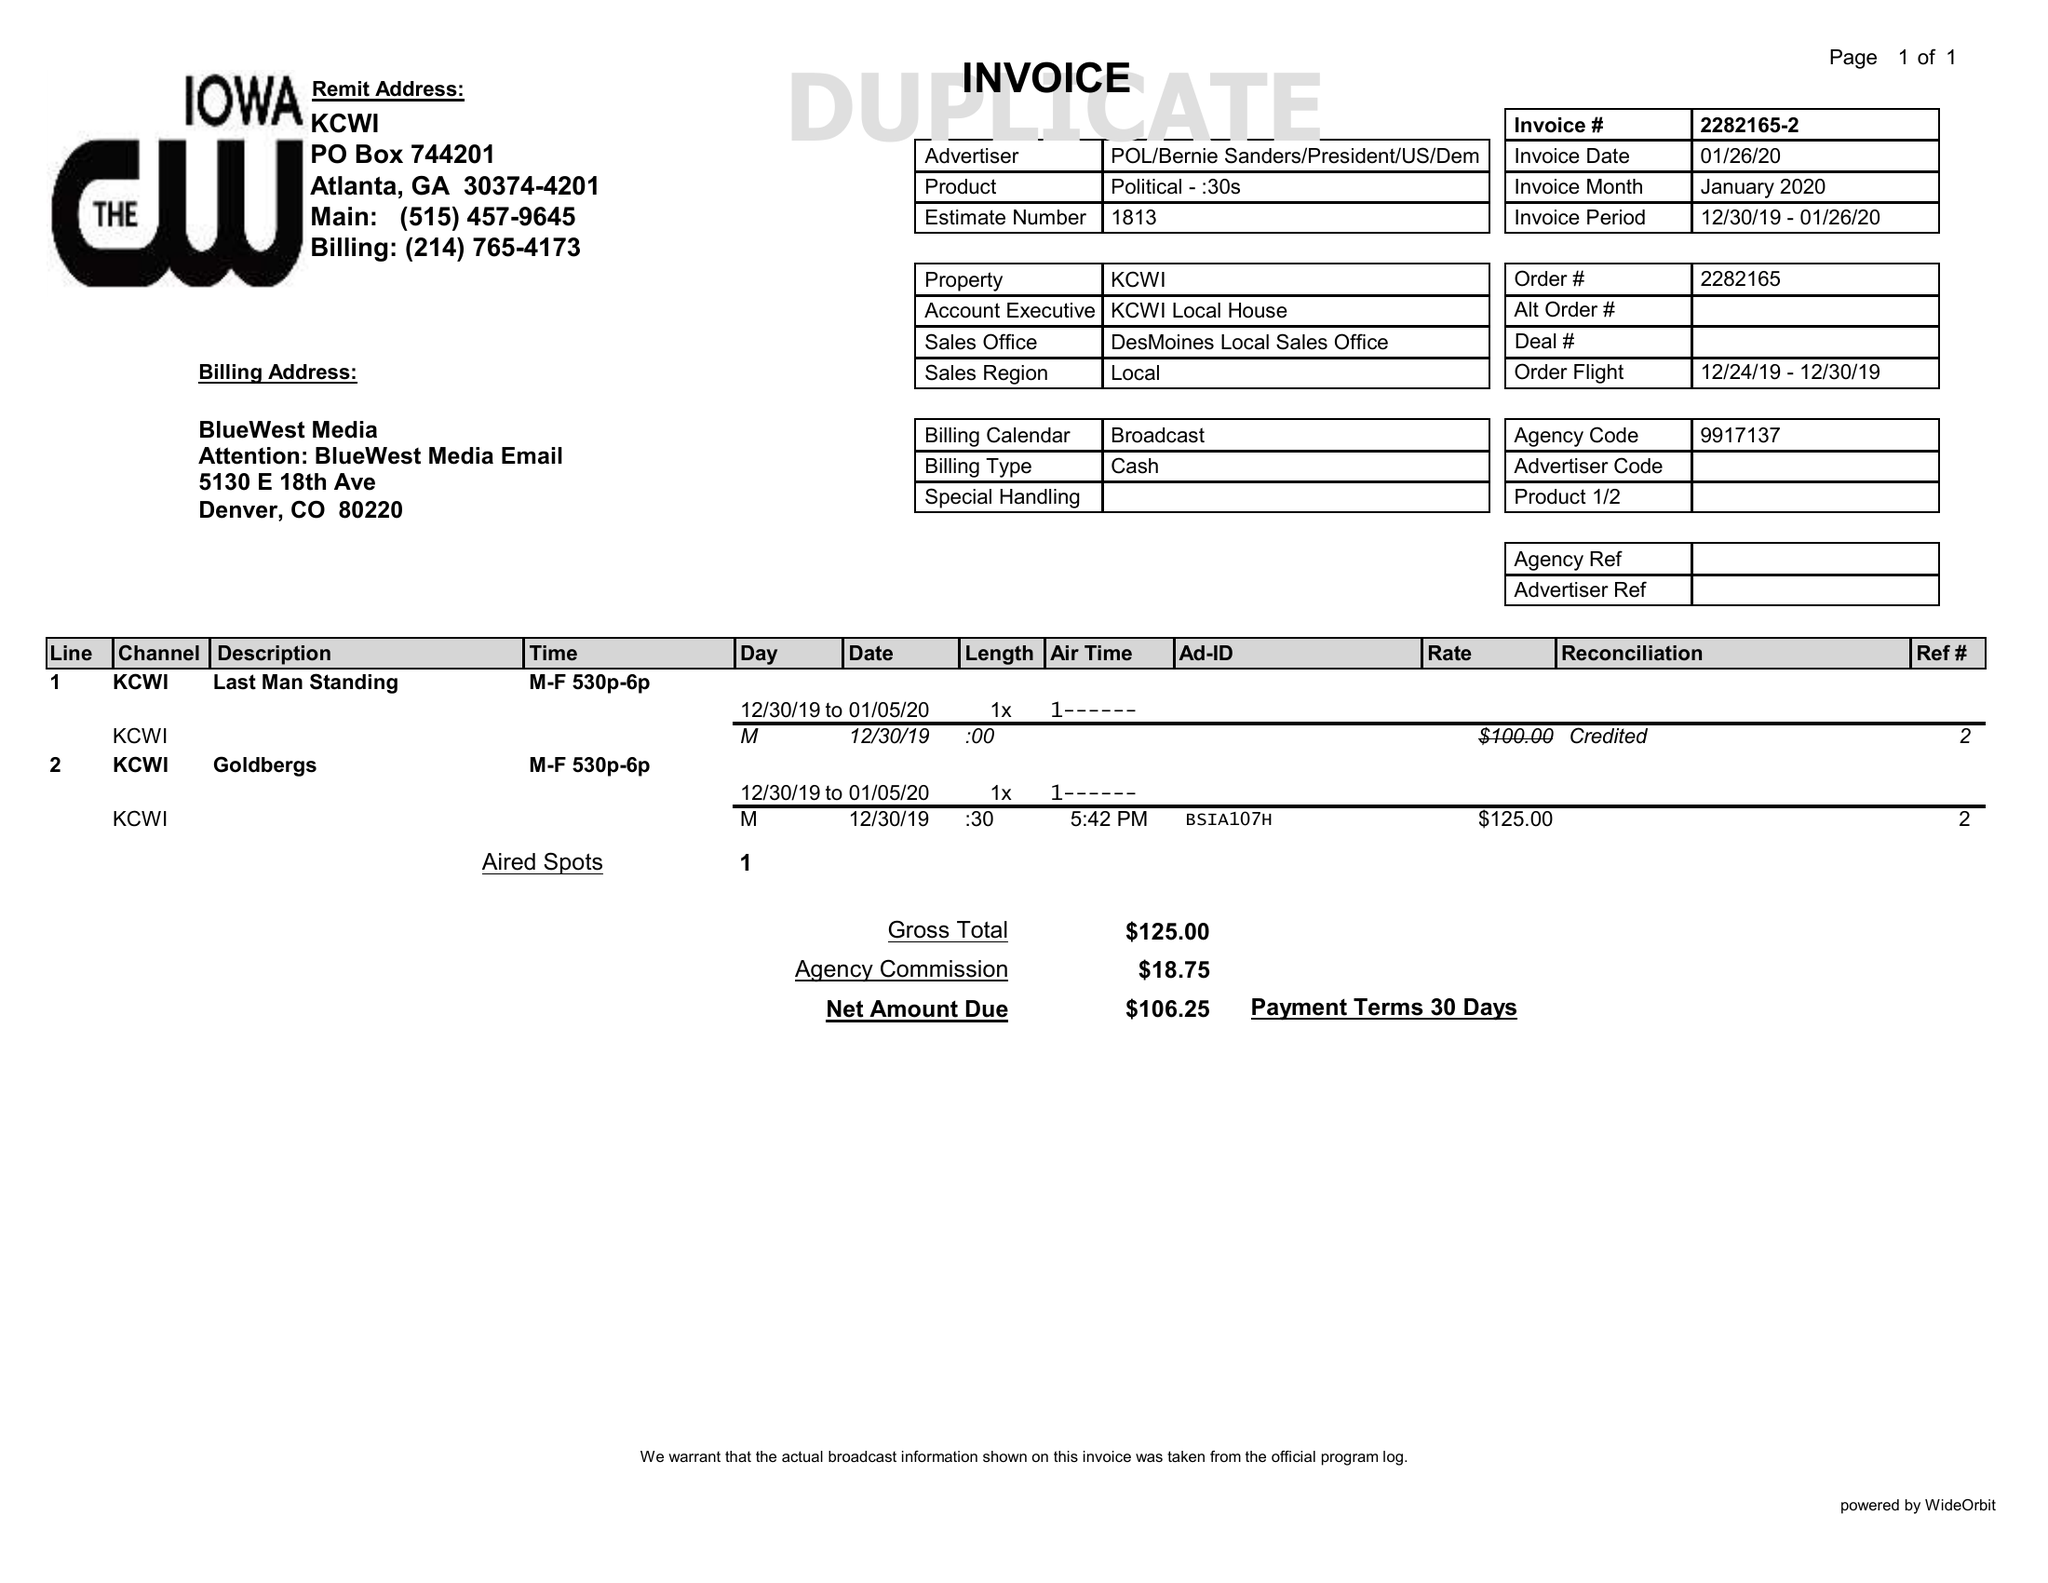What is the value for the flight_to?
Answer the question using a single word or phrase. 12/30/19 